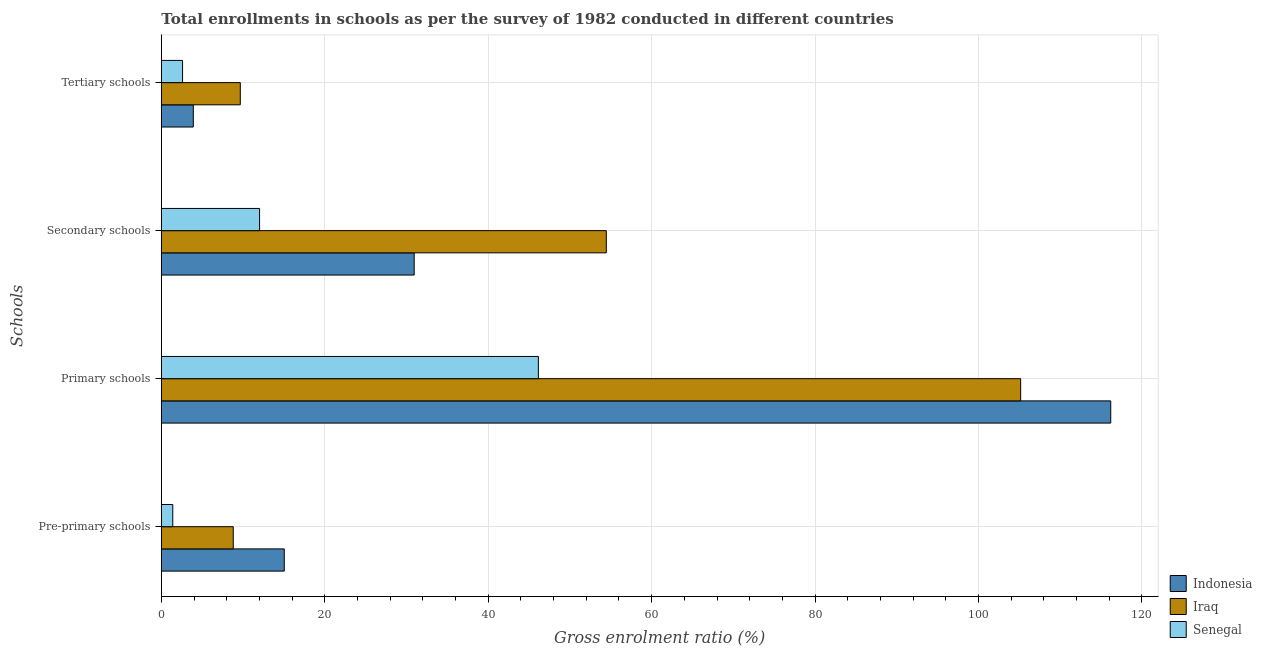How many different coloured bars are there?
Provide a succinct answer. 3. Are the number of bars per tick equal to the number of legend labels?
Offer a very short reply. Yes. How many bars are there on the 4th tick from the bottom?
Ensure brevity in your answer.  3. What is the label of the 3rd group of bars from the top?
Give a very brief answer. Primary schools. What is the gross enrolment ratio in tertiary schools in Indonesia?
Make the answer very short. 3.91. Across all countries, what is the maximum gross enrolment ratio in pre-primary schools?
Keep it short and to the point. 15.04. Across all countries, what is the minimum gross enrolment ratio in primary schools?
Offer a very short reply. 46.14. In which country was the gross enrolment ratio in secondary schools maximum?
Offer a terse response. Iraq. In which country was the gross enrolment ratio in secondary schools minimum?
Provide a succinct answer. Senegal. What is the total gross enrolment ratio in primary schools in the graph?
Provide a short and direct response. 267.47. What is the difference between the gross enrolment ratio in primary schools in Iraq and that in Indonesia?
Provide a short and direct response. -11.02. What is the difference between the gross enrolment ratio in pre-primary schools in Indonesia and the gross enrolment ratio in primary schools in Senegal?
Make the answer very short. -31.1. What is the average gross enrolment ratio in tertiary schools per country?
Your answer should be compact. 5.39. What is the difference between the gross enrolment ratio in tertiary schools and gross enrolment ratio in secondary schools in Iraq?
Provide a succinct answer. -44.79. In how many countries, is the gross enrolment ratio in primary schools greater than 36 %?
Offer a very short reply. 3. What is the ratio of the gross enrolment ratio in tertiary schools in Iraq to that in Indonesia?
Your answer should be compact. 2.47. Is the difference between the gross enrolment ratio in primary schools in Iraq and Senegal greater than the difference between the gross enrolment ratio in secondary schools in Iraq and Senegal?
Your answer should be very brief. Yes. What is the difference between the highest and the second highest gross enrolment ratio in primary schools?
Your response must be concise. 11.02. What is the difference between the highest and the lowest gross enrolment ratio in primary schools?
Your answer should be compact. 70.04. Is the sum of the gross enrolment ratio in pre-primary schools in Senegal and Iraq greater than the maximum gross enrolment ratio in tertiary schools across all countries?
Make the answer very short. Yes. Is it the case that in every country, the sum of the gross enrolment ratio in pre-primary schools and gross enrolment ratio in primary schools is greater than the sum of gross enrolment ratio in secondary schools and gross enrolment ratio in tertiary schools?
Your answer should be very brief. No. What does the 1st bar from the top in Primary schools represents?
Your answer should be very brief. Senegal. What does the 2nd bar from the bottom in Pre-primary schools represents?
Provide a short and direct response. Iraq. Is it the case that in every country, the sum of the gross enrolment ratio in pre-primary schools and gross enrolment ratio in primary schools is greater than the gross enrolment ratio in secondary schools?
Provide a succinct answer. Yes. How many bars are there?
Provide a succinct answer. 12. Are all the bars in the graph horizontal?
Provide a short and direct response. Yes. Are the values on the major ticks of X-axis written in scientific E-notation?
Your answer should be very brief. No. Where does the legend appear in the graph?
Keep it short and to the point. Bottom right. How many legend labels are there?
Provide a short and direct response. 3. What is the title of the graph?
Ensure brevity in your answer.  Total enrollments in schools as per the survey of 1982 conducted in different countries. Does "Poland" appear as one of the legend labels in the graph?
Ensure brevity in your answer.  No. What is the label or title of the Y-axis?
Keep it short and to the point. Schools. What is the Gross enrolment ratio (%) in Indonesia in Pre-primary schools?
Provide a short and direct response. 15.04. What is the Gross enrolment ratio (%) in Iraq in Pre-primary schools?
Your answer should be very brief. 8.8. What is the Gross enrolment ratio (%) in Senegal in Pre-primary schools?
Keep it short and to the point. 1.4. What is the Gross enrolment ratio (%) in Indonesia in Primary schools?
Provide a short and direct response. 116.18. What is the Gross enrolment ratio (%) in Iraq in Primary schools?
Ensure brevity in your answer.  105.16. What is the Gross enrolment ratio (%) of Senegal in Primary schools?
Your response must be concise. 46.14. What is the Gross enrolment ratio (%) in Indonesia in Secondary schools?
Offer a very short reply. 30.94. What is the Gross enrolment ratio (%) in Iraq in Secondary schools?
Provide a succinct answer. 54.45. What is the Gross enrolment ratio (%) of Senegal in Secondary schools?
Provide a short and direct response. 12.02. What is the Gross enrolment ratio (%) in Indonesia in Tertiary schools?
Provide a short and direct response. 3.91. What is the Gross enrolment ratio (%) of Iraq in Tertiary schools?
Make the answer very short. 9.66. What is the Gross enrolment ratio (%) in Senegal in Tertiary schools?
Your answer should be compact. 2.6. Across all Schools, what is the maximum Gross enrolment ratio (%) in Indonesia?
Your response must be concise. 116.18. Across all Schools, what is the maximum Gross enrolment ratio (%) of Iraq?
Your response must be concise. 105.16. Across all Schools, what is the maximum Gross enrolment ratio (%) of Senegal?
Give a very brief answer. 46.14. Across all Schools, what is the minimum Gross enrolment ratio (%) of Indonesia?
Your answer should be very brief. 3.91. Across all Schools, what is the minimum Gross enrolment ratio (%) in Iraq?
Make the answer very short. 8.8. Across all Schools, what is the minimum Gross enrolment ratio (%) in Senegal?
Keep it short and to the point. 1.4. What is the total Gross enrolment ratio (%) of Indonesia in the graph?
Make the answer very short. 166.08. What is the total Gross enrolment ratio (%) in Iraq in the graph?
Your response must be concise. 178.07. What is the total Gross enrolment ratio (%) of Senegal in the graph?
Keep it short and to the point. 62.17. What is the difference between the Gross enrolment ratio (%) in Indonesia in Pre-primary schools and that in Primary schools?
Ensure brevity in your answer.  -101.13. What is the difference between the Gross enrolment ratio (%) of Iraq in Pre-primary schools and that in Primary schools?
Keep it short and to the point. -96.35. What is the difference between the Gross enrolment ratio (%) in Senegal in Pre-primary schools and that in Primary schools?
Provide a succinct answer. -44.74. What is the difference between the Gross enrolment ratio (%) in Indonesia in Pre-primary schools and that in Secondary schools?
Offer a terse response. -15.9. What is the difference between the Gross enrolment ratio (%) of Iraq in Pre-primary schools and that in Secondary schools?
Keep it short and to the point. -45.65. What is the difference between the Gross enrolment ratio (%) of Senegal in Pre-primary schools and that in Secondary schools?
Provide a short and direct response. -10.62. What is the difference between the Gross enrolment ratio (%) in Indonesia in Pre-primary schools and that in Tertiary schools?
Provide a succinct answer. 11.13. What is the difference between the Gross enrolment ratio (%) in Iraq in Pre-primary schools and that in Tertiary schools?
Keep it short and to the point. -0.86. What is the difference between the Gross enrolment ratio (%) in Senegal in Pre-primary schools and that in Tertiary schools?
Your answer should be very brief. -1.2. What is the difference between the Gross enrolment ratio (%) in Indonesia in Primary schools and that in Secondary schools?
Give a very brief answer. 85.24. What is the difference between the Gross enrolment ratio (%) in Iraq in Primary schools and that in Secondary schools?
Your response must be concise. 50.7. What is the difference between the Gross enrolment ratio (%) of Senegal in Primary schools and that in Secondary schools?
Make the answer very short. 34.12. What is the difference between the Gross enrolment ratio (%) in Indonesia in Primary schools and that in Tertiary schools?
Your response must be concise. 112.26. What is the difference between the Gross enrolment ratio (%) in Iraq in Primary schools and that in Tertiary schools?
Keep it short and to the point. 95.49. What is the difference between the Gross enrolment ratio (%) in Senegal in Primary schools and that in Tertiary schools?
Keep it short and to the point. 43.54. What is the difference between the Gross enrolment ratio (%) of Indonesia in Secondary schools and that in Tertiary schools?
Make the answer very short. 27.03. What is the difference between the Gross enrolment ratio (%) of Iraq in Secondary schools and that in Tertiary schools?
Your response must be concise. 44.79. What is the difference between the Gross enrolment ratio (%) in Senegal in Secondary schools and that in Tertiary schools?
Make the answer very short. 9.43. What is the difference between the Gross enrolment ratio (%) in Indonesia in Pre-primary schools and the Gross enrolment ratio (%) in Iraq in Primary schools?
Provide a succinct answer. -90.11. What is the difference between the Gross enrolment ratio (%) of Indonesia in Pre-primary schools and the Gross enrolment ratio (%) of Senegal in Primary schools?
Provide a succinct answer. -31.1. What is the difference between the Gross enrolment ratio (%) of Iraq in Pre-primary schools and the Gross enrolment ratio (%) of Senegal in Primary schools?
Offer a very short reply. -37.34. What is the difference between the Gross enrolment ratio (%) of Indonesia in Pre-primary schools and the Gross enrolment ratio (%) of Iraq in Secondary schools?
Your response must be concise. -39.41. What is the difference between the Gross enrolment ratio (%) in Indonesia in Pre-primary schools and the Gross enrolment ratio (%) in Senegal in Secondary schools?
Provide a succinct answer. 3.02. What is the difference between the Gross enrolment ratio (%) of Iraq in Pre-primary schools and the Gross enrolment ratio (%) of Senegal in Secondary schools?
Provide a succinct answer. -3.22. What is the difference between the Gross enrolment ratio (%) of Indonesia in Pre-primary schools and the Gross enrolment ratio (%) of Iraq in Tertiary schools?
Your answer should be compact. 5.38. What is the difference between the Gross enrolment ratio (%) of Indonesia in Pre-primary schools and the Gross enrolment ratio (%) of Senegal in Tertiary schools?
Offer a terse response. 12.45. What is the difference between the Gross enrolment ratio (%) in Iraq in Pre-primary schools and the Gross enrolment ratio (%) in Senegal in Tertiary schools?
Your response must be concise. 6.2. What is the difference between the Gross enrolment ratio (%) of Indonesia in Primary schools and the Gross enrolment ratio (%) of Iraq in Secondary schools?
Your response must be concise. 61.73. What is the difference between the Gross enrolment ratio (%) in Indonesia in Primary schools and the Gross enrolment ratio (%) in Senegal in Secondary schools?
Keep it short and to the point. 104.15. What is the difference between the Gross enrolment ratio (%) in Iraq in Primary schools and the Gross enrolment ratio (%) in Senegal in Secondary schools?
Your answer should be very brief. 93.13. What is the difference between the Gross enrolment ratio (%) in Indonesia in Primary schools and the Gross enrolment ratio (%) in Iraq in Tertiary schools?
Give a very brief answer. 106.51. What is the difference between the Gross enrolment ratio (%) of Indonesia in Primary schools and the Gross enrolment ratio (%) of Senegal in Tertiary schools?
Your answer should be compact. 113.58. What is the difference between the Gross enrolment ratio (%) in Iraq in Primary schools and the Gross enrolment ratio (%) in Senegal in Tertiary schools?
Your answer should be very brief. 102.56. What is the difference between the Gross enrolment ratio (%) in Indonesia in Secondary schools and the Gross enrolment ratio (%) in Iraq in Tertiary schools?
Keep it short and to the point. 21.28. What is the difference between the Gross enrolment ratio (%) of Indonesia in Secondary schools and the Gross enrolment ratio (%) of Senegal in Tertiary schools?
Ensure brevity in your answer.  28.34. What is the difference between the Gross enrolment ratio (%) of Iraq in Secondary schools and the Gross enrolment ratio (%) of Senegal in Tertiary schools?
Keep it short and to the point. 51.85. What is the average Gross enrolment ratio (%) in Indonesia per Schools?
Provide a short and direct response. 41.52. What is the average Gross enrolment ratio (%) in Iraq per Schools?
Your answer should be very brief. 44.52. What is the average Gross enrolment ratio (%) in Senegal per Schools?
Give a very brief answer. 15.54. What is the difference between the Gross enrolment ratio (%) in Indonesia and Gross enrolment ratio (%) in Iraq in Pre-primary schools?
Ensure brevity in your answer.  6.24. What is the difference between the Gross enrolment ratio (%) of Indonesia and Gross enrolment ratio (%) of Senegal in Pre-primary schools?
Your response must be concise. 13.64. What is the difference between the Gross enrolment ratio (%) in Iraq and Gross enrolment ratio (%) in Senegal in Pre-primary schools?
Your answer should be very brief. 7.4. What is the difference between the Gross enrolment ratio (%) in Indonesia and Gross enrolment ratio (%) in Iraq in Primary schools?
Provide a succinct answer. 11.02. What is the difference between the Gross enrolment ratio (%) in Indonesia and Gross enrolment ratio (%) in Senegal in Primary schools?
Offer a very short reply. 70.04. What is the difference between the Gross enrolment ratio (%) of Iraq and Gross enrolment ratio (%) of Senegal in Primary schools?
Provide a short and direct response. 59.01. What is the difference between the Gross enrolment ratio (%) in Indonesia and Gross enrolment ratio (%) in Iraq in Secondary schools?
Offer a terse response. -23.51. What is the difference between the Gross enrolment ratio (%) in Indonesia and Gross enrolment ratio (%) in Senegal in Secondary schools?
Offer a terse response. 18.92. What is the difference between the Gross enrolment ratio (%) of Iraq and Gross enrolment ratio (%) of Senegal in Secondary schools?
Make the answer very short. 42.43. What is the difference between the Gross enrolment ratio (%) of Indonesia and Gross enrolment ratio (%) of Iraq in Tertiary schools?
Ensure brevity in your answer.  -5.75. What is the difference between the Gross enrolment ratio (%) in Indonesia and Gross enrolment ratio (%) in Senegal in Tertiary schools?
Offer a very short reply. 1.31. What is the difference between the Gross enrolment ratio (%) of Iraq and Gross enrolment ratio (%) of Senegal in Tertiary schools?
Give a very brief answer. 7.06. What is the ratio of the Gross enrolment ratio (%) in Indonesia in Pre-primary schools to that in Primary schools?
Provide a short and direct response. 0.13. What is the ratio of the Gross enrolment ratio (%) in Iraq in Pre-primary schools to that in Primary schools?
Ensure brevity in your answer.  0.08. What is the ratio of the Gross enrolment ratio (%) in Senegal in Pre-primary schools to that in Primary schools?
Provide a succinct answer. 0.03. What is the ratio of the Gross enrolment ratio (%) in Indonesia in Pre-primary schools to that in Secondary schools?
Keep it short and to the point. 0.49. What is the ratio of the Gross enrolment ratio (%) of Iraq in Pre-primary schools to that in Secondary schools?
Offer a very short reply. 0.16. What is the ratio of the Gross enrolment ratio (%) in Senegal in Pre-primary schools to that in Secondary schools?
Provide a short and direct response. 0.12. What is the ratio of the Gross enrolment ratio (%) of Indonesia in Pre-primary schools to that in Tertiary schools?
Your answer should be very brief. 3.84. What is the ratio of the Gross enrolment ratio (%) in Iraq in Pre-primary schools to that in Tertiary schools?
Offer a very short reply. 0.91. What is the ratio of the Gross enrolment ratio (%) in Senegal in Pre-primary schools to that in Tertiary schools?
Provide a succinct answer. 0.54. What is the ratio of the Gross enrolment ratio (%) of Indonesia in Primary schools to that in Secondary schools?
Make the answer very short. 3.75. What is the ratio of the Gross enrolment ratio (%) of Iraq in Primary schools to that in Secondary schools?
Make the answer very short. 1.93. What is the ratio of the Gross enrolment ratio (%) in Senegal in Primary schools to that in Secondary schools?
Your answer should be compact. 3.84. What is the ratio of the Gross enrolment ratio (%) of Indonesia in Primary schools to that in Tertiary schools?
Give a very brief answer. 29.68. What is the ratio of the Gross enrolment ratio (%) in Iraq in Primary schools to that in Tertiary schools?
Provide a succinct answer. 10.88. What is the ratio of the Gross enrolment ratio (%) in Senegal in Primary schools to that in Tertiary schools?
Make the answer very short. 17.75. What is the ratio of the Gross enrolment ratio (%) of Indonesia in Secondary schools to that in Tertiary schools?
Your response must be concise. 7.91. What is the ratio of the Gross enrolment ratio (%) in Iraq in Secondary schools to that in Tertiary schools?
Your answer should be very brief. 5.63. What is the ratio of the Gross enrolment ratio (%) in Senegal in Secondary schools to that in Tertiary schools?
Make the answer very short. 4.63. What is the difference between the highest and the second highest Gross enrolment ratio (%) of Indonesia?
Provide a short and direct response. 85.24. What is the difference between the highest and the second highest Gross enrolment ratio (%) of Iraq?
Your answer should be compact. 50.7. What is the difference between the highest and the second highest Gross enrolment ratio (%) in Senegal?
Make the answer very short. 34.12. What is the difference between the highest and the lowest Gross enrolment ratio (%) of Indonesia?
Keep it short and to the point. 112.26. What is the difference between the highest and the lowest Gross enrolment ratio (%) in Iraq?
Your answer should be compact. 96.35. What is the difference between the highest and the lowest Gross enrolment ratio (%) in Senegal?
Give a very brief answer. 44.74. 